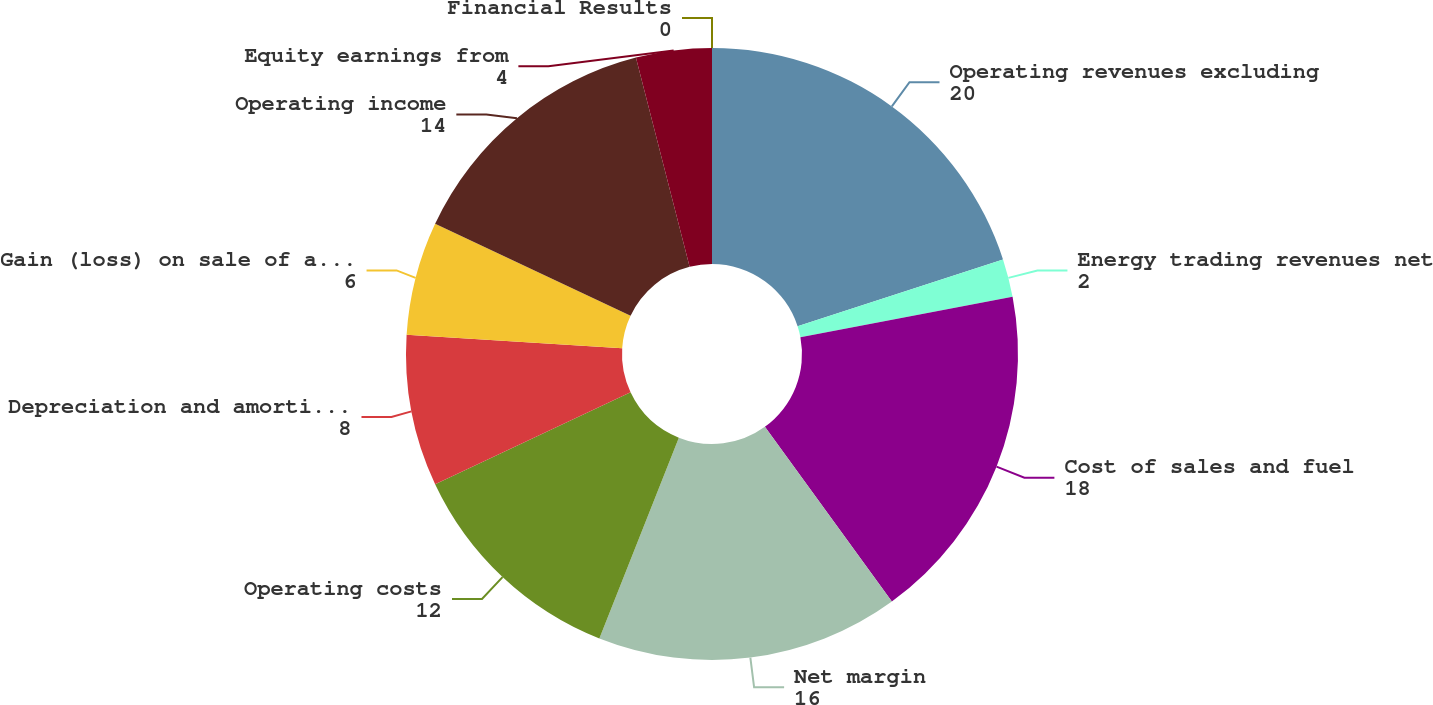<chart> <loc_0><loc_0><loc_500><loc_500><pie_chart><fcel>Financial Results<fcel>Operating revenues excluding<fcel>Energy trading revenues net<fcel>Cost of sales and fuel<fcel>Net margin<fcel>Operating costs<fcel>Depreciation and amortization<fcel>Gain (loss) on sale of assets<fcel>Operating income<fcel>Equity earnings from<nl><fcel>0.0%<fcel>20.0%<fcel>2.0%<fcel>18.0%<fcel>16.0%<fcel>12.0%<fcel>8.0%<fcel>6.0%<fcel>14.0%<fcel>4.0%<nl></chart> 